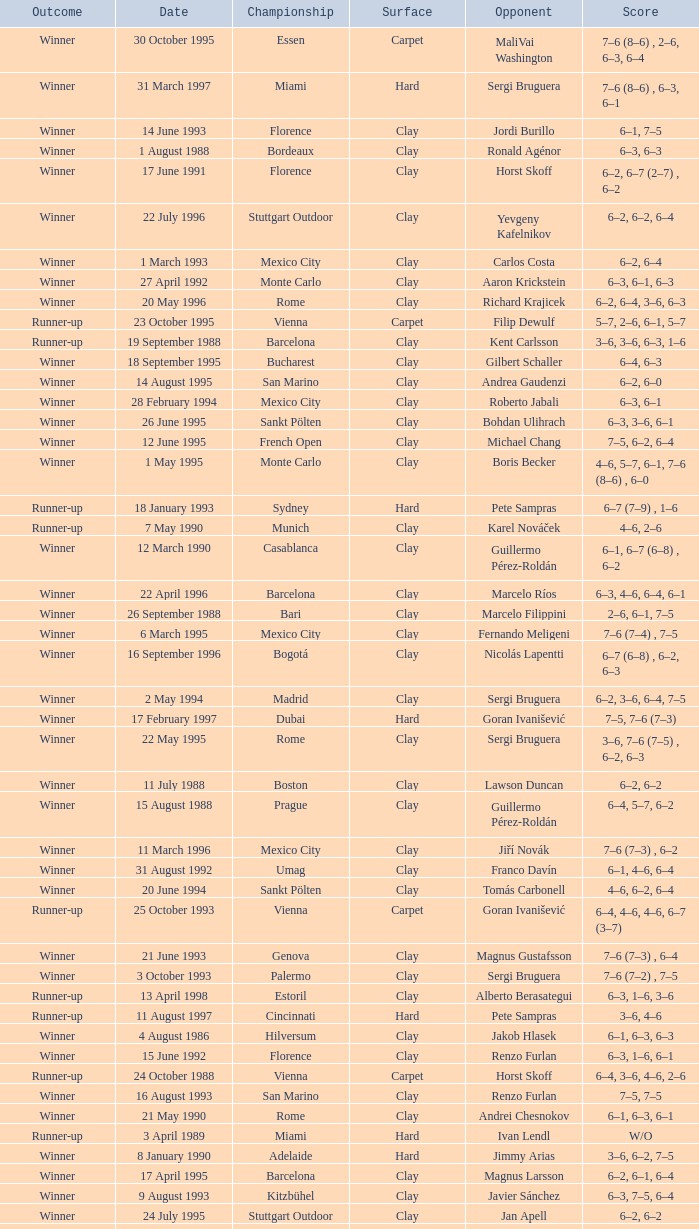What is the score when the championship is rome and the opponent is richard krajicek? 6–2, 6–4, 3–6, 6–3. 